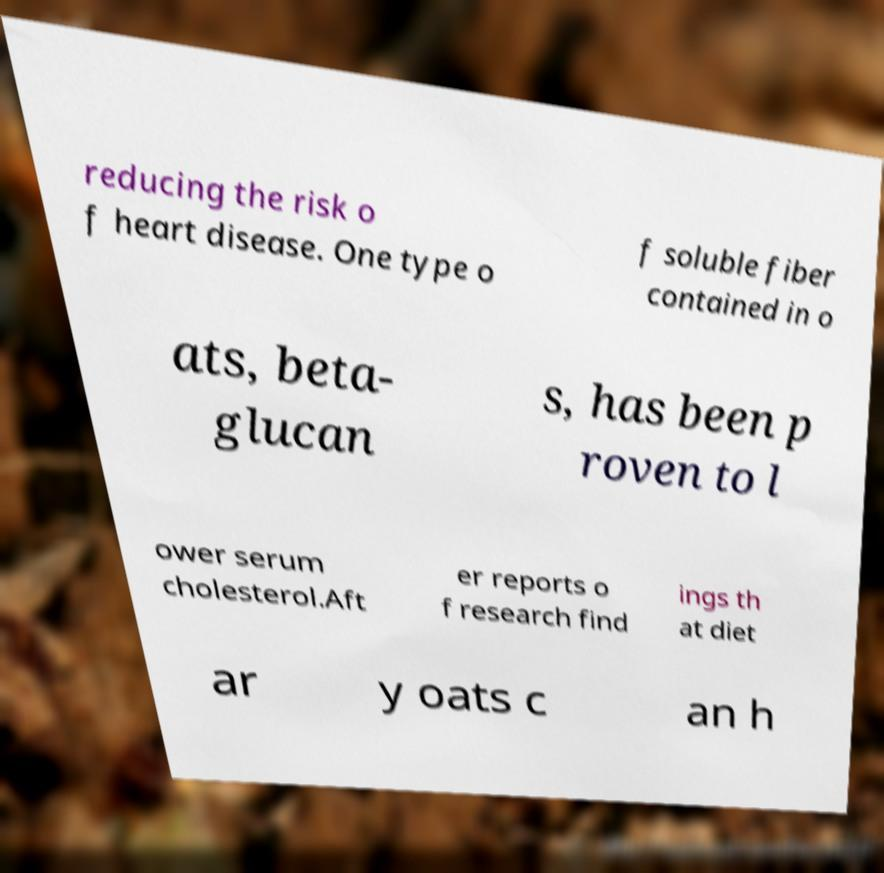What messages or text are displayed in this image? I need them in a readable, typed format. reducing the risk o f heart disease. One type o f soluble fiber contained in o ats, beta- glucan s, has been p roven to l ower serum cholesterol.Aft er reports o f research find ings th at diet ar y oats c an h 